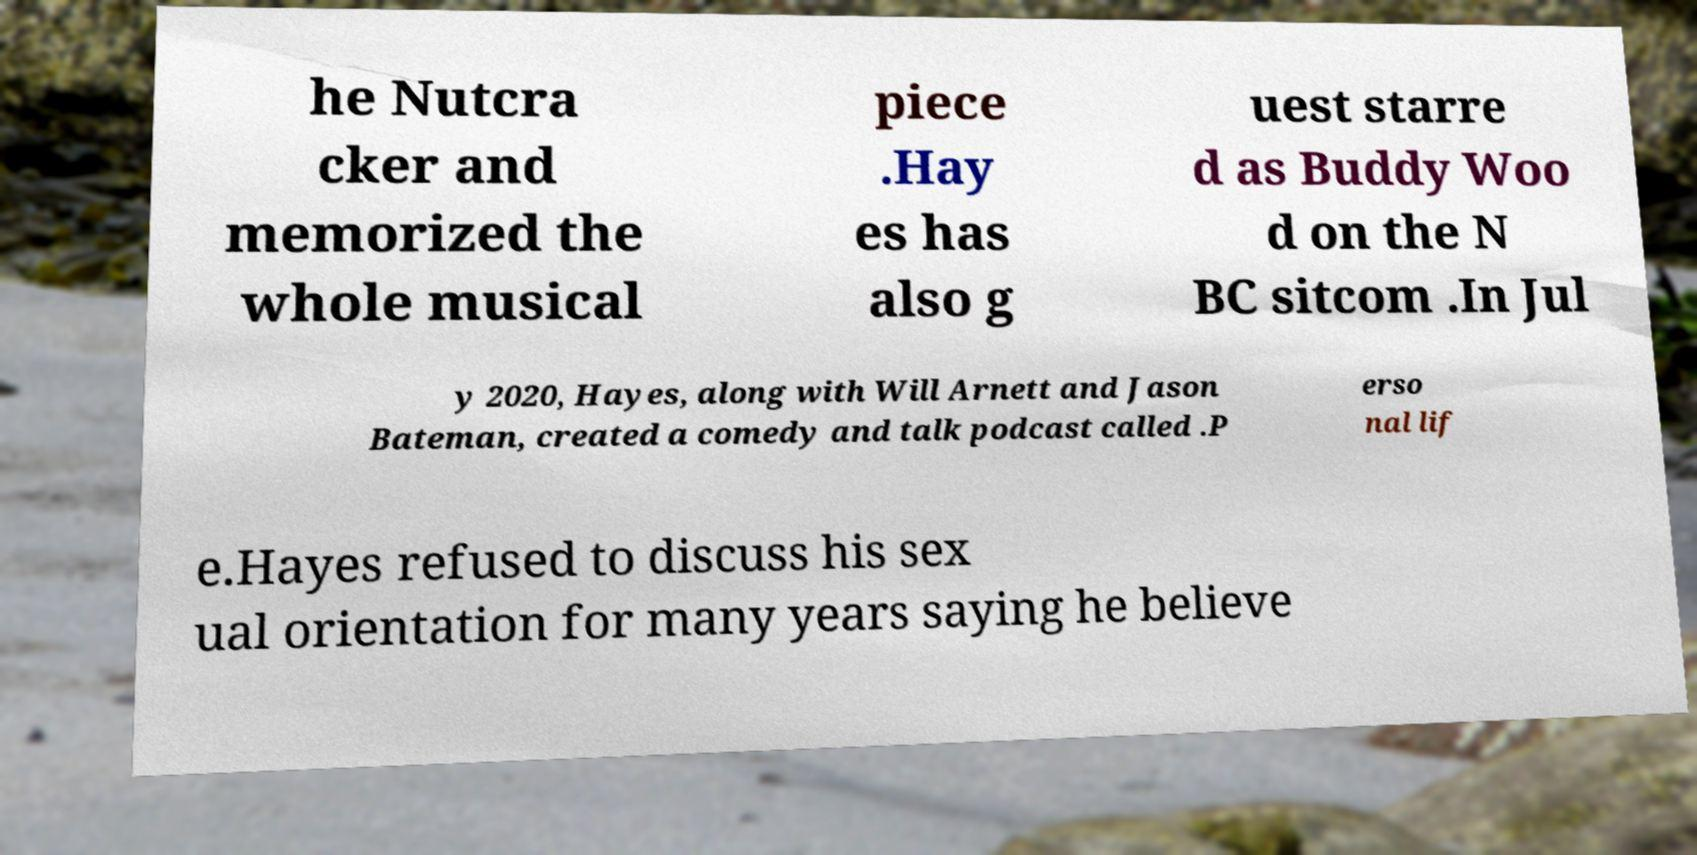Please identify and transcribe the text found in this image. he Nutcra cker and memorized the whole musical piece .Hay es has also g uest starre d as Buddy Woo d on the N BC sitcom .In Jul y 2020, Hayes, along with Will Arnett and Jason Bateman, created a comedy and talk podcast called .P erso nal lif e.Hayes refused to discuss his sex ual orientation for many years saying he believe 